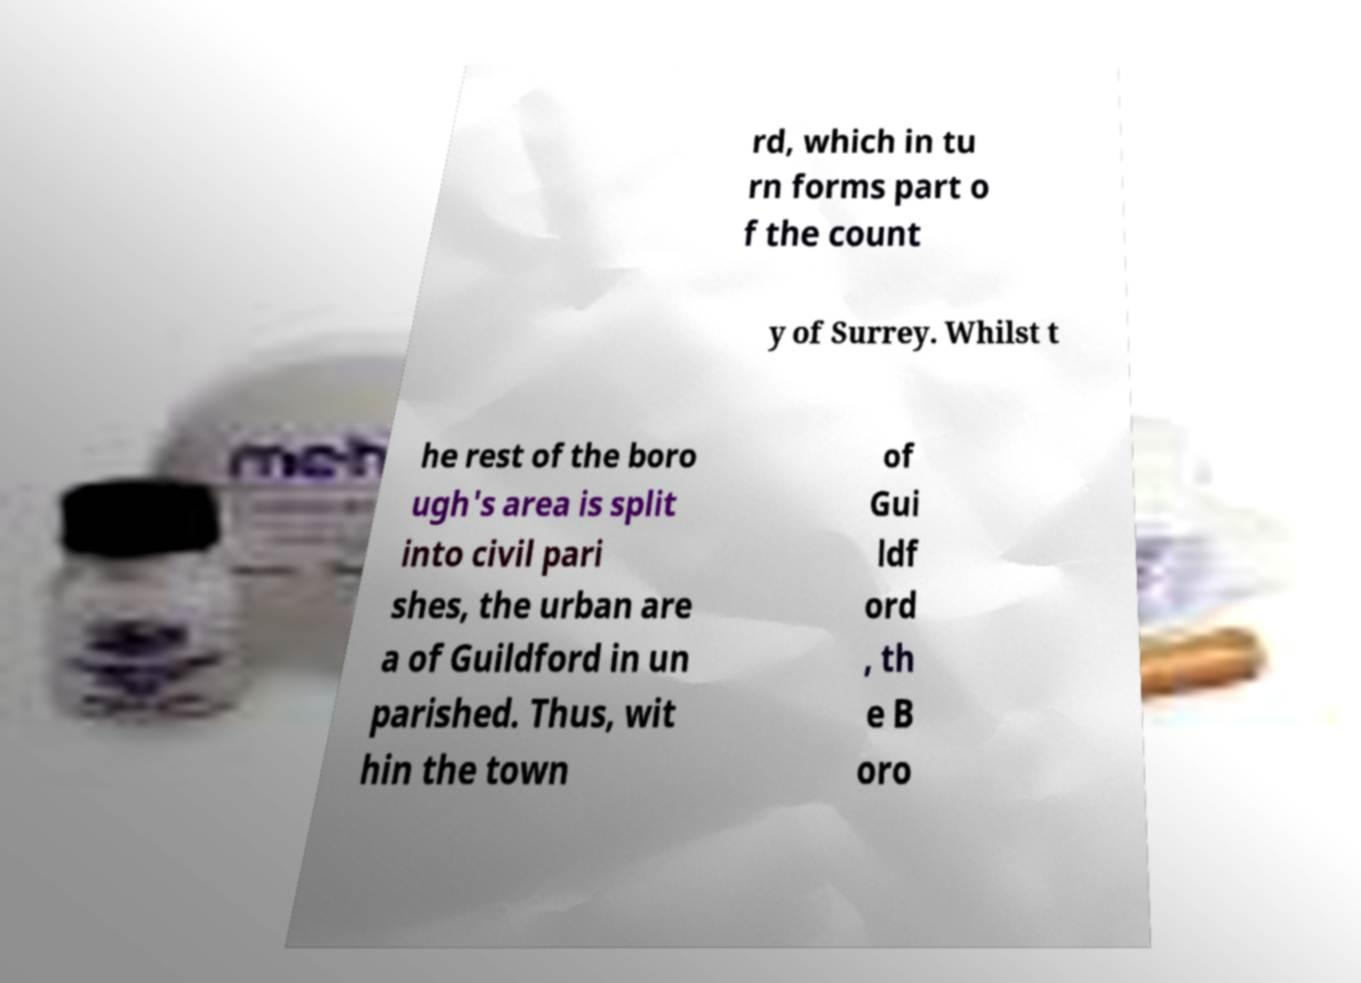Please read and relay the text visible in this image. What does it say? rd, which in tu rn forms part o f the count y of Surrey. Whilst t he rest of the boro ugh's area is split into civil pari shes, the urban are a of Guildford in un parished. Thus, wit hin the town of Gui ldf ord , th e B oro 